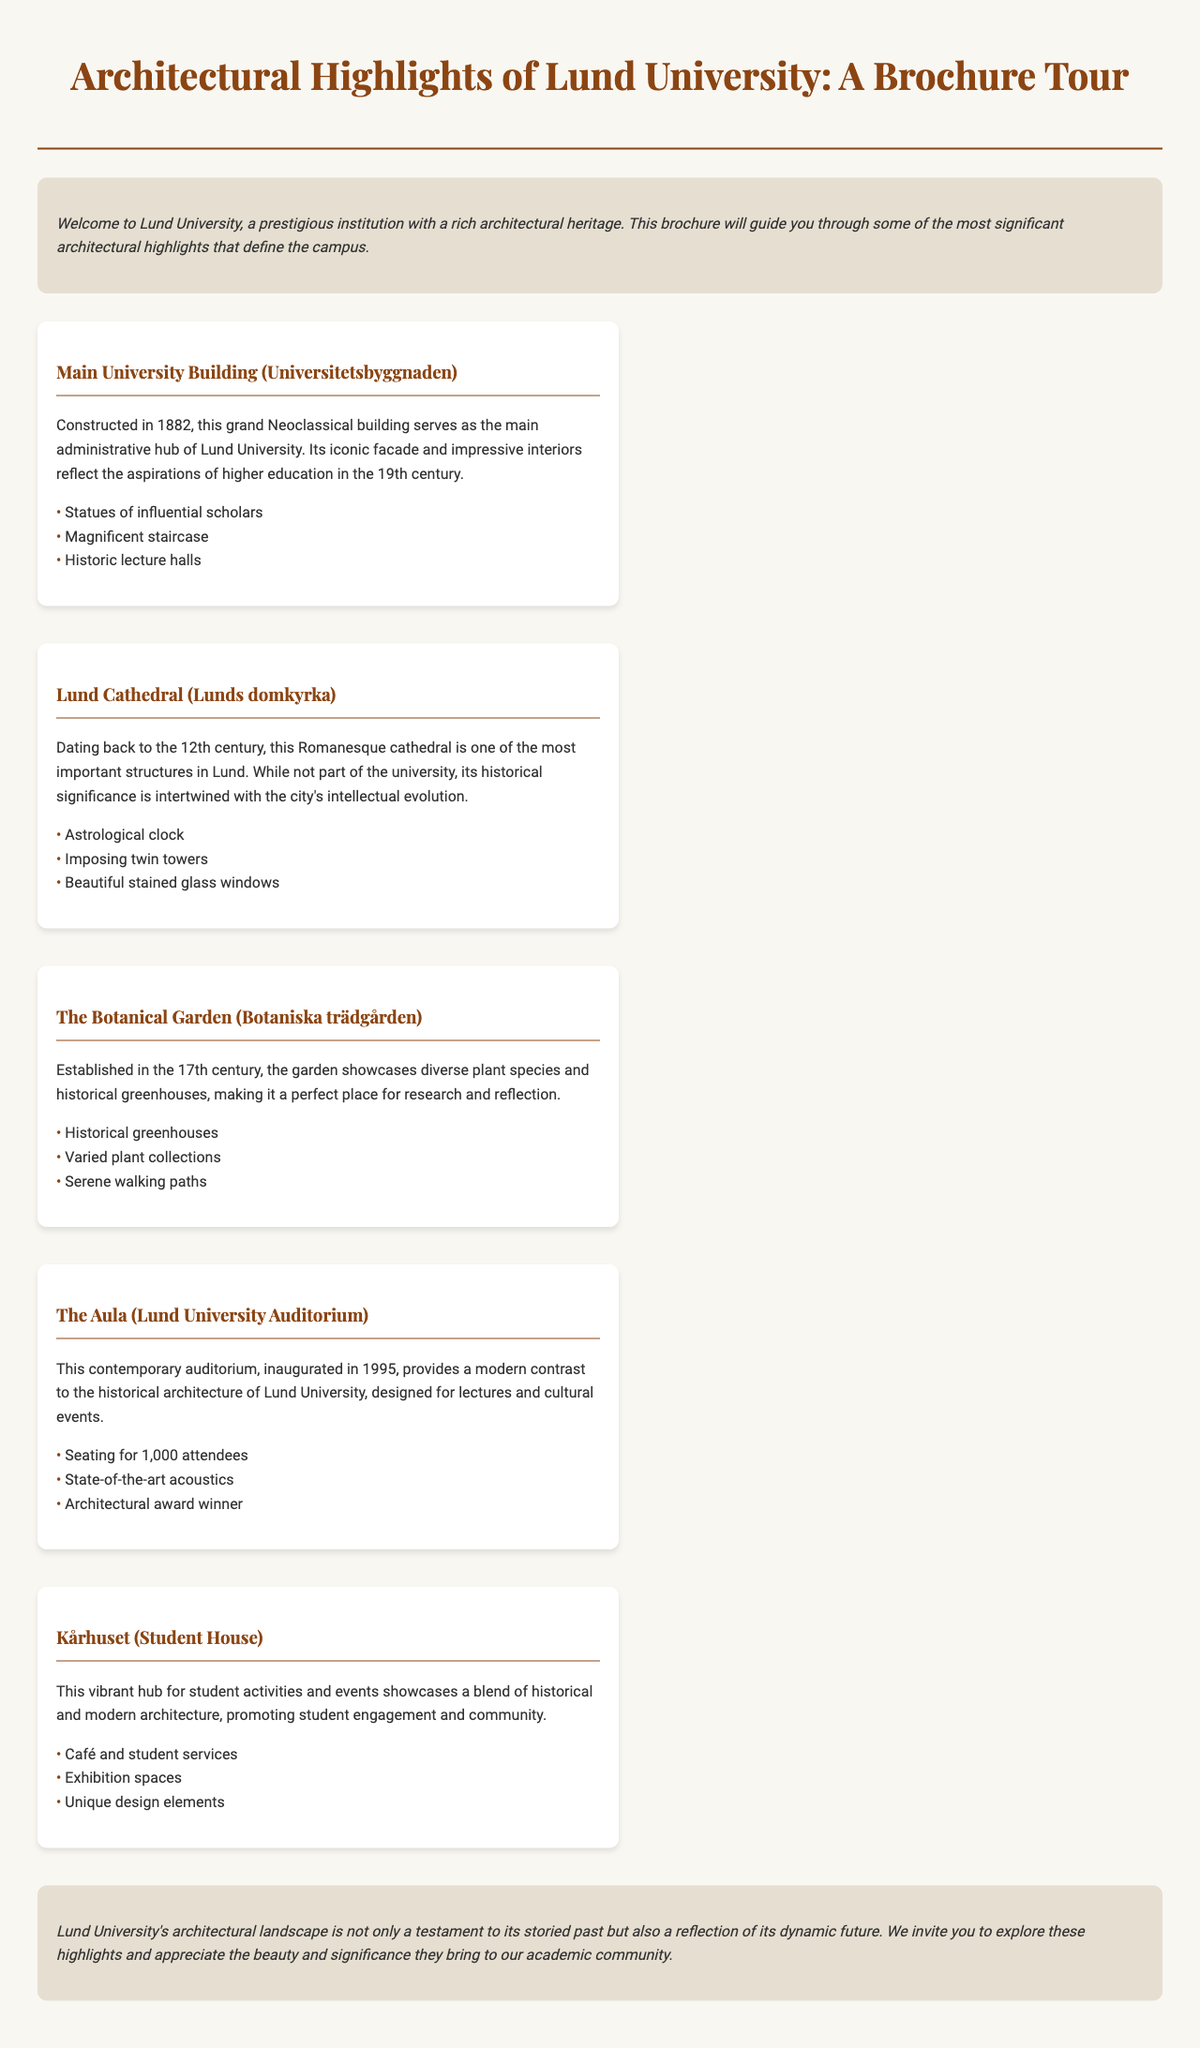What year was the Main University Building constructed? The document states that the Main University Building was constructed in 1882.
Answer: 1882 What is the architectural style of Lund Cathedral? The document describes Lund Cathedral as a Romanesque cathedral.
Answer: Romanesque How many attendees can The Aula seat? The document specifies that The Aula can seat 1,000 attendees.
Answer: 1,000 What is the purpose of Kårhuset? The document indicates that Kårhuset is a hub for student activities and events.
Answer: Student activities What is a unique feature of the Botanical Garden? The document mentions historical greenhouses as a feature of the Botanical Garden.
Answer: Historical greenhouses What modern element contrasts the historical architecture at Lund University? The document highlights a contemporary auditorium as a modern element.
Answer: Contemporary auditorium What is significant about the features of the Main University Building? The document lists statues of influential scholars as a significant feature.
Answer: Statues of influential scholars Why is Lund Cathedral significant to the city's intellectual evolution? The document notes that Lund Cathedral's historical significance is intertwined with the city's intellectual evolution.
Answer: Historical significance What year was The Aula inaugurated? The document states that The Aula was inaugurated in 1995.
Answer: 1995 